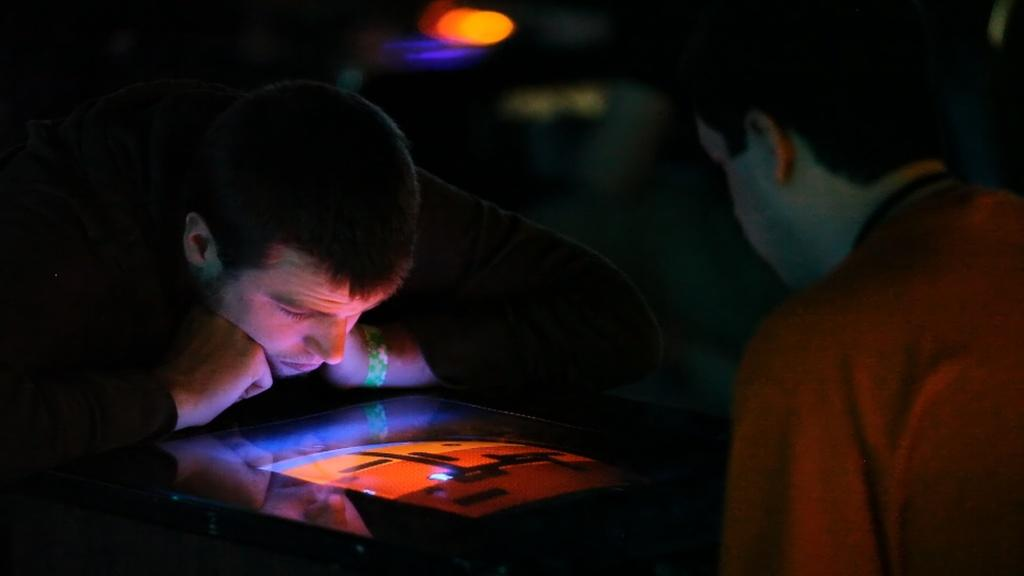How many people are in the image? There are two men in the image. What are the men doing in the image? The men are looking at a screen. Can you describe the background of the image? The background of the image is dark. What type of snakes can be seen slithering on the screen in the image? There are no snakes present in the image; the men are looking at a screen, but there is no indication of what is on the screen. 